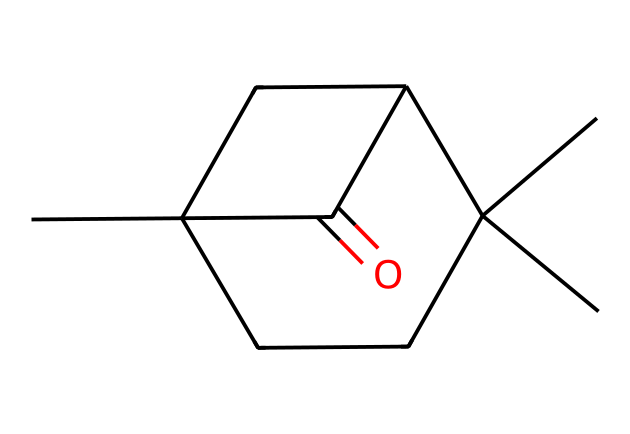What is the chemical name of the compound represented by this SMILES? The SMILES notation represents the molecular structure of camphor, which is a ketone. The arrangement of carbons and the presence of a carbonyl group indicates that this compound can chemically be identified as camphor.
Answer: camphor How many carbon atoms are present in camphor? By analyzing the SMILES representation, we can count the carbon atoms represented by the letters "C." In this structure, there are ten "C" characters, indicating there are ten carbon atoms in camphor.
Answer: ten Is camphor a cyclic compound? The structure contains a fused cyclic framework, which is indicated by the presence of numerals (1 and 2) in the SMILES that denote ring closures. Therefore, camphor is a cyclic compound.
Answer: yes How many hydrogen atoms are associated with camphor? Each carbon in organic molecules typically bonds to enough hydrogens to make four total bonds. After counting the structure and accounting for the carbonyl group, camphor has fourteen hydrogen atoms.
Answer: fourteen What functional group is present in camphor? The carbonyl (C=O) group is clearly visible in the structure, which classifies camphor as a ketone. This is a defining feature of ketones.
Answer: ketone Can you identify a common use of camphor in traditional medicine? Camphor is commonly used for its medicinal properties, particularly as a topical analgesic and cough suppressant. Its therapeutic uses are well recognized in traditional Indian medicine.
Answer: analgesic 